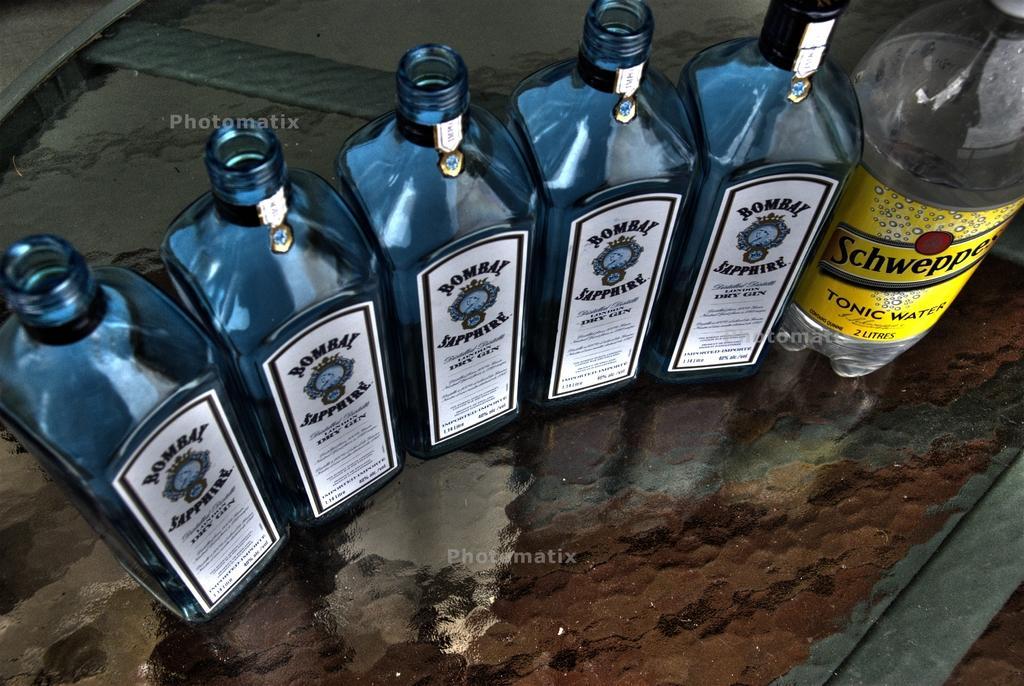Could you give a brief overview of what you see in this image? In this picture we can see some bottles on the table. 